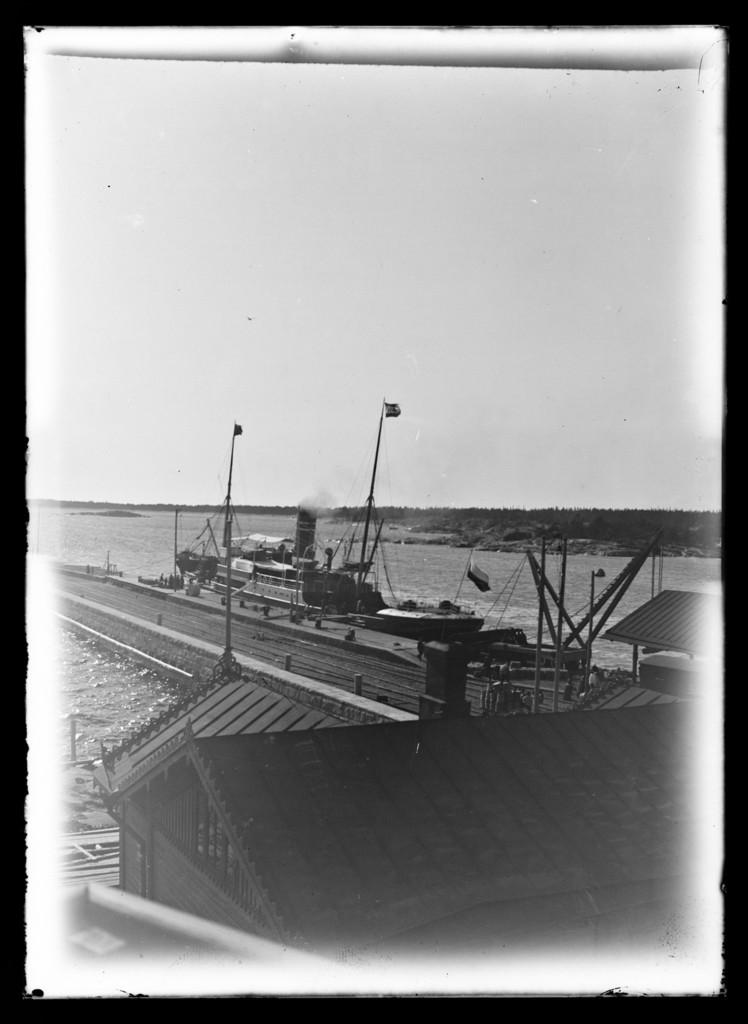What structure is located at the bottom of the image? There is a building at the bottom of the image. What can be seen crossing over a body of water in the image? There is a bridge in the image. What type of watercraft is visible in the image? There is a yacht in the image. What type of vegetation is in the backdrop of the image? There are trees in the backdrop of the image. What is the condition of the sky in the image? The sky is clear in the image. What is the color scheme of the image? The image is black and white. What type of food is being served on the bridge in the image? There is no food visible in the image, and the bridge is not serving any food. Is there a rainstorm happening in the image? No, the sky is clear in the image, and there is no indication of a rainstorm. 